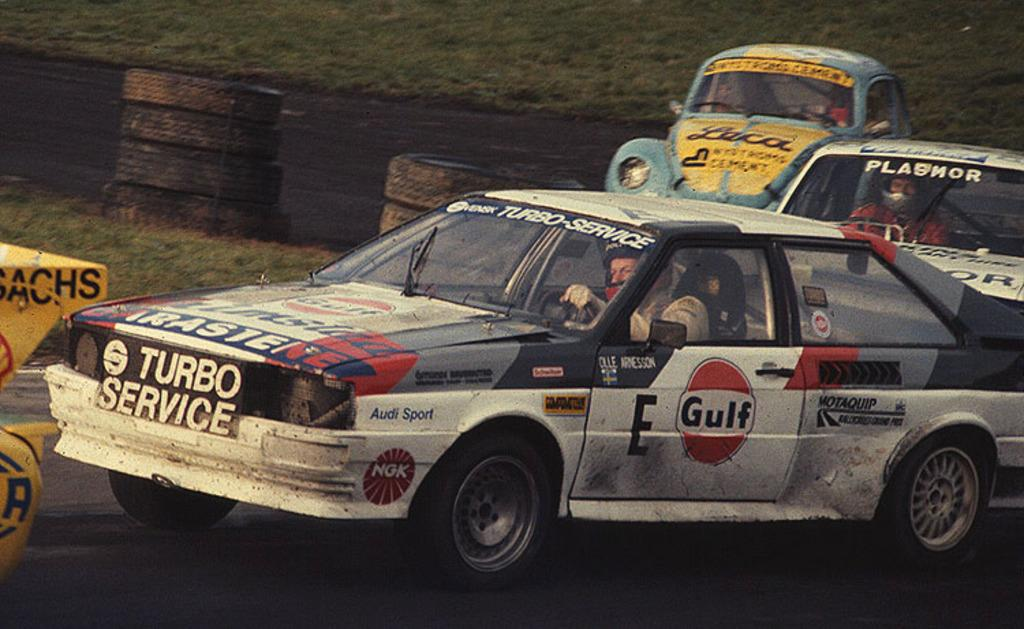What type of vehicles can be seen on the road in the image? There are cars on the road in the image. Can you describe the condition of the car on the side of the road? There is a car on the side of the road in the image. What objects are on the side of the road in the image? There are tires on the side of the road in the image. What type of vegetation is visible on the ground in the image? Grass is visible on the ground in the image. What type of wristwatch can be seen on the car's dashboard in the image? There is no wristwatch visible on the car's dashboard in the image. What type of sticks are being used to play a game in the image? There are no sticks or games present in the image. 